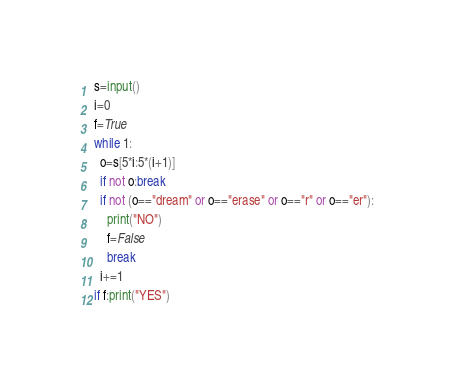<code> <loc_0><loc_0><loc_500><loc_500><_Python_>s=input()
i=0
f=True
while 1:
  o=s[5*i:5*(i+1)]
  if not o:break
  if not (o=="dream" or o=="erase" or o=="r" or o=="er"):
    print("NO")
    f=False
    break
  i+=1
if f:print("YES")</code> 